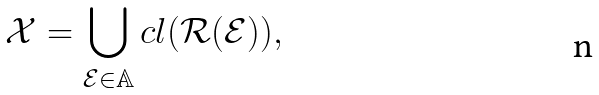<formula> <loc_0><loc_0><loc_500><loc_500>\mathcal { X } = \bigcup _ { \mathcal { E } \in \mathbb { A } } c l ( \mathcal { R } ( \mathcal { E } ) ) ,</formula> 